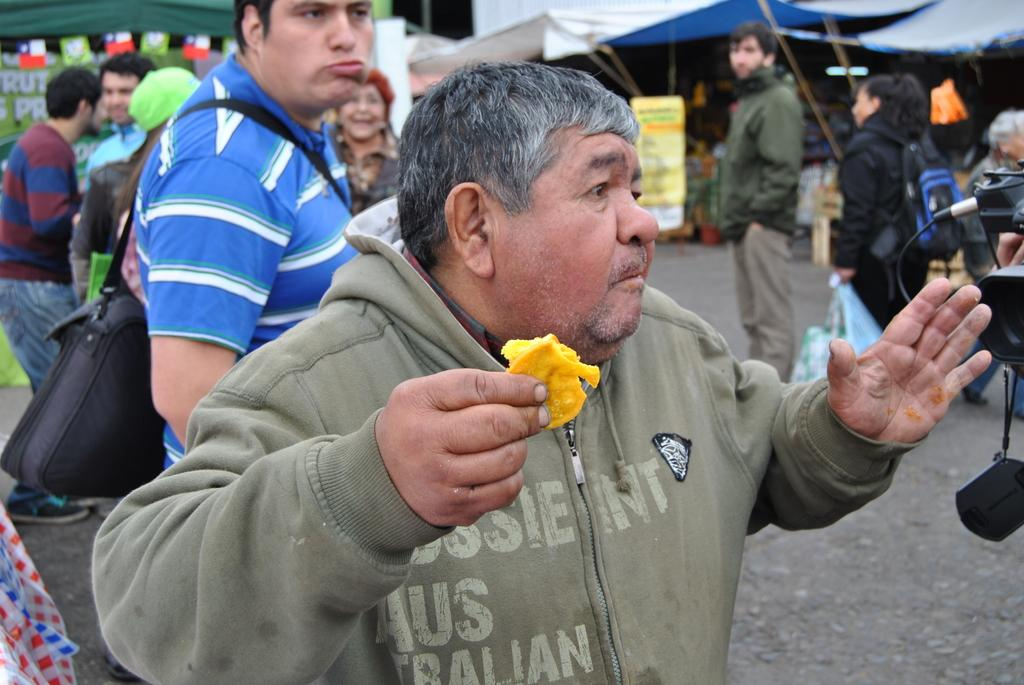How many people are in the image? There is a group of people in the image, but the exact number is not specified. Where are the people located in the image? The people are standing on the road in the image. What object is used to capture the image? There is a camera in the image. What can be seen hanging above the people? There is a banner in the image. What type of structures are visible in the background of the image? There are stalls visible in the background of the image. What type of quartz can be seen in the image? There is no quartz present in the image. What time of day is depicted in the image? The time of day is not specified in the image. 